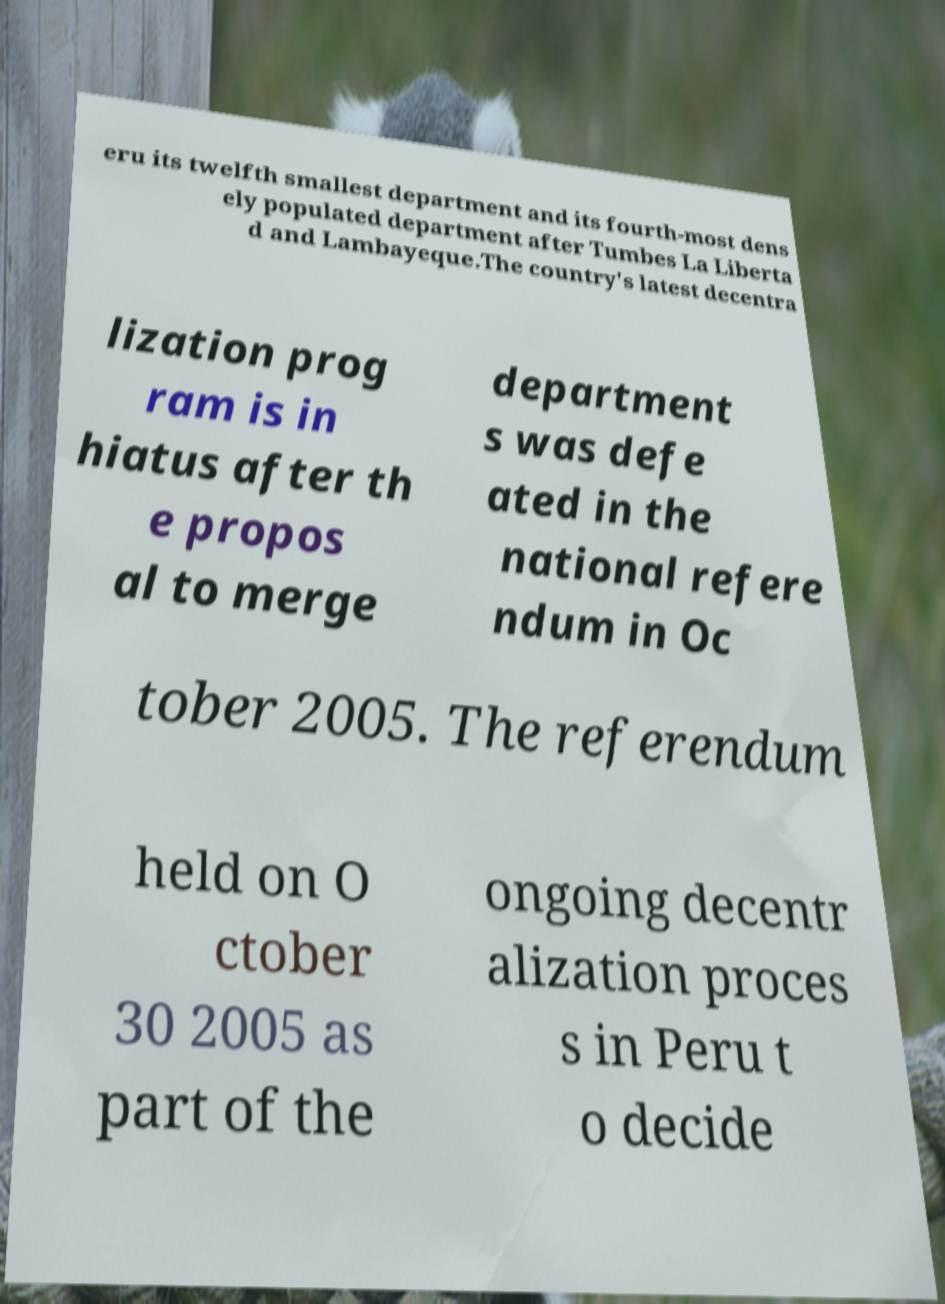Could you assist in decoding the text presented in this image and type it out clearly? eru its twelfth smallest department and its fourth-most dens ely populated department after Tumbes La Liberta d and Lambayeque.The country's latest decentra lization prog ram is in hiatus after th e propos al to merge department s was defe ated in the national refere ndum in Oc tober 2005. The referendum held on O ctober 30 2005 as part of the ongoing decentr alization proces s in Peru t o decide 